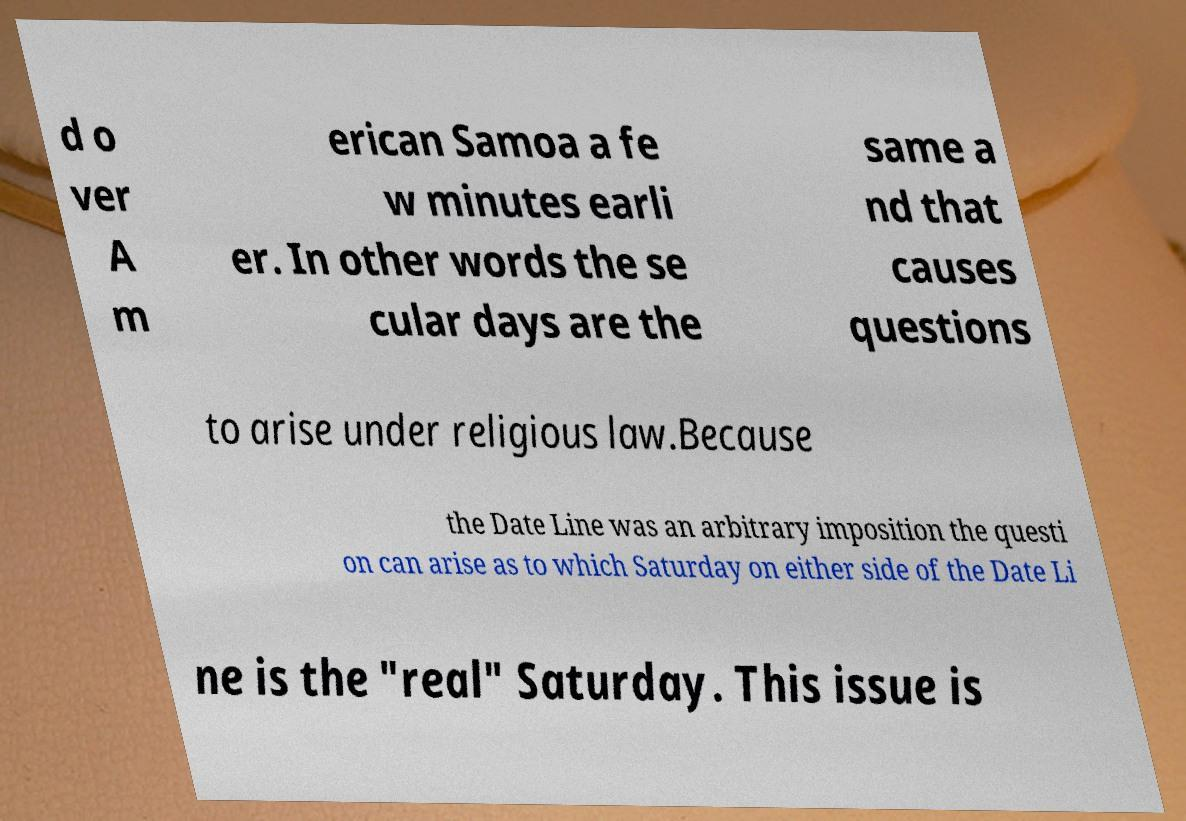Please identify and transcribe the text found in this image. d o ver A m erican Samoa a fe w minutes earli er. In other words the se cular days are the same a nd that causes questions to arise under religious law.Because the Date Line was an arbitrary imposition the questi on can arise as to which Saturday on either side of the Date Li ne is the "real" Saturday. This issue is 